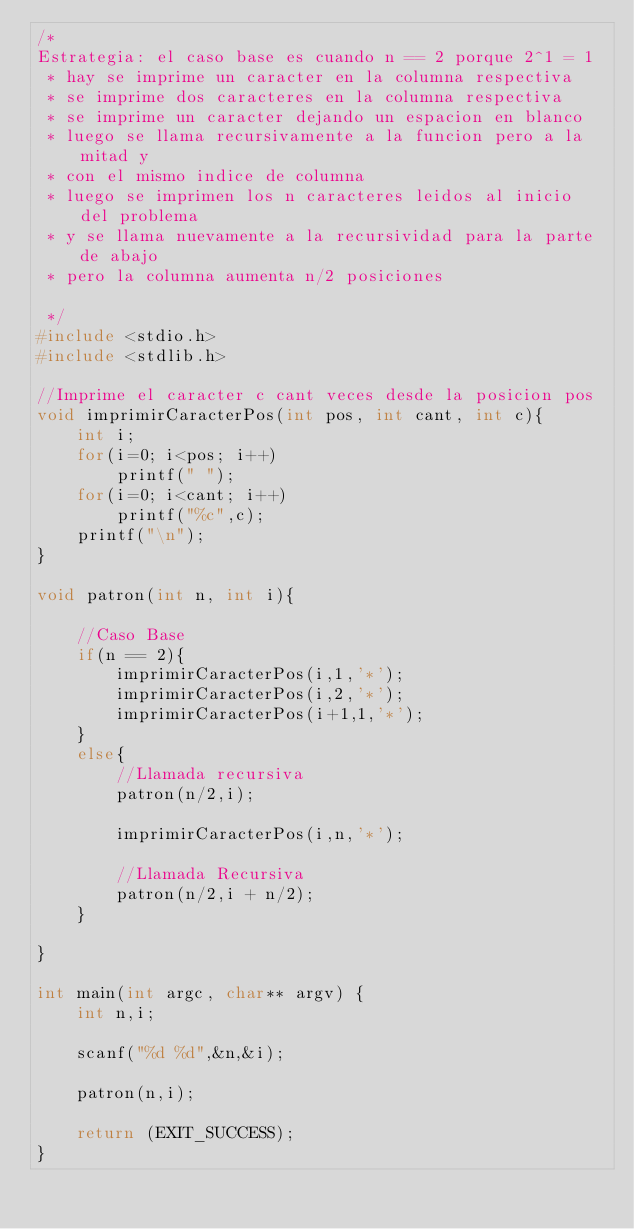<code> <loc_0><loc_0><loc_500><loc_500><_C_>/*
Estrategia: el caso base es cuando n == 2 porque 2^1 = 1
 * hay se imprime un caracter en la columna respectiva
 * se imprime dos caracteres en la columna respectiva
 * se imprime un caracter dejando un espacion en blanco
 * luego se llama recursivamente a la funcion pero a la mitad y 
 * con el mismo indice de columna
 * luego se imprimen los n caracteres leidos al inicio del problema
 * y se llama nuevamente a la recursividad para la parte de abajo
 * pero la columna aumenta n/2 posiciones 
 
 */
#include <stdio.h>
#include <stdlib.h>

//Imprime el caracter c cant veces desde la posicion pos
void imprimirCaracterPos(int pos, int cant, int c){
    int i;
    for(i=0; i<pos; i++)
        printf(" ");
    for(i=0; i<cant; i++)
        printf("%c",c);
    printf("\n");
}

void patron(int n, int i){
    
    //Caso Base
    if(n == 2){
        imprimirCaracterPos(i,1,'*');
        imprimirCaracterPos(i,2,'*');
        imprimirCaracterPos(i+1,1,'*');
    }
    else{
        //Llamada recursiva
        patron(n/2,i);
        
        imprimirCaracterPos(i,n,'*');
        
        //Llamada Recursiva
        patron(n/2,i + n/2);
    }
    
}

int main(int argc, char** argv) {
    int n,i;
    
    scanf("%d %d",&n,&i);
    
    patron(n,i);
    
    return (EXIT_SUCCESS);
}

</code> 